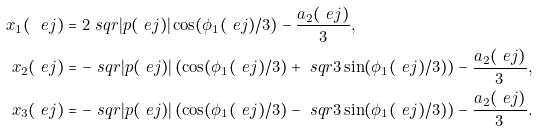<formula> <loc_0><loc_0><loc_500><loc_500>x _ { 1 } ( \ e j ) & = 2 \ s q r { | p ( \ e j ) | } \cos ( \phi _ { 1 } ( \ e j ) / 3 ) - \frac { a _ { 2 } ( \ e j ) } { 3 } , \\ x _ { 2 } ( \ e j ) & = - \ s q r { | p ( \ e j ) | } \left ( \cos ( \phi _ { 1 } ( \ e j ) / 3 ) + \ s q r { 3 } \sin ( \phi _ { 1 } ( \ e j ) / 3 ) \right ) - \frac { a _ { 2 } ( \ e j ) } { 3 } , \\ x _ { 3 } ( \ e j ) & = - \ s q r { | p ( \ e j ) | } \left ( \cos ( \phi _ { 1 } ( \ e j ) / 3 ) - \ s q r { 3 } \sin ( \phi _ { 1 } ( \ e j ) / 3 ) \right ) - \frac { a _ { 2 } ( \ e j ) } { 3 } .</formula> 